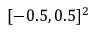Convert formula to latex. <formula><loc_0><loc_0><loc_500><loc_500>[ - 0 . 5 , 0 . 5 ] ^ { 2 }</formula> 